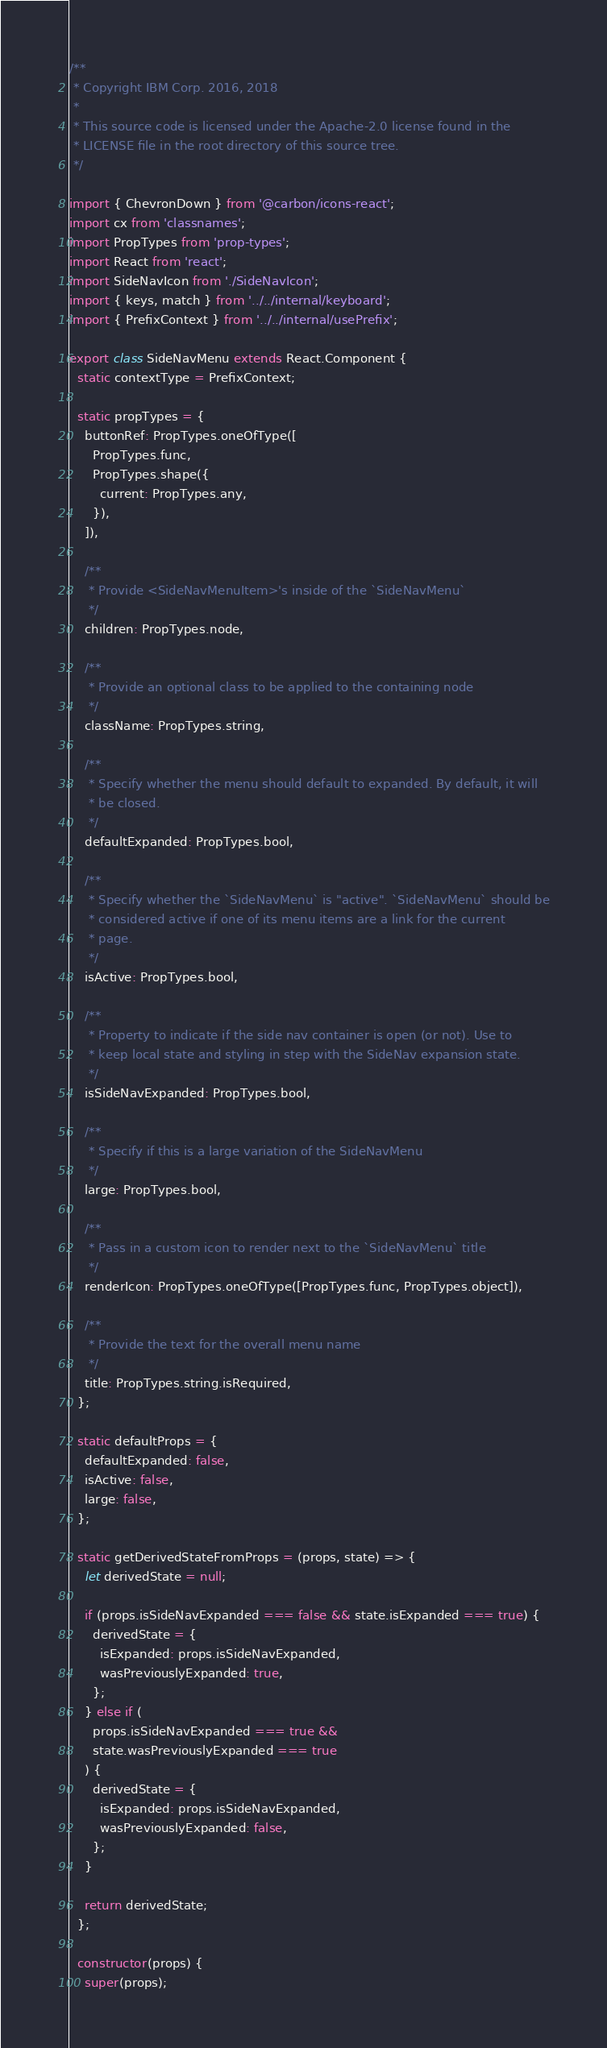<code> <loc_0><loc_0><loc_500><loc_500><_JavaScript_>/**
 * Copyright IBM Corp. 2016, 2018
 *
 * This source code is licensed under the Apache-2.0 license found in the
 * LICENSE file in the root directory of this source tree.
 */

import { ChevronDown } from '@carbon/icons-react';
import cx from 'classnames';
import PropTypes from 'prop-types';
import React from 'react';
import SideNavIcon from './SideNavIcon';
import { keys, match } from '../../internal/keyboard';
import { PrefixContext } from '../../internal/usePrefix';

export class SideNavMenu extends React.Component {
  static contextType = PrefixContext;

  static propTypes = {
    buttonRef: PropTypes.oneOfType([
      PropTypes.func,
      PropTypes.shape({
        current: PropTypes.any,
      }),
    ]),

    /**
     * Provide <SideNavMenuItem>'s inside of the `SideNavMenu`
     */
    children: PropTypes.node,

    /**
     * Provide an optional class to be applied to the containing node
     */
    className: PropTypes.string,

    /**
     * Specify whether the menu should default to expanded. By default, it will
     * be closed.
     */
    defaultExpanded: PropTypes.bool,

    /**
     * Specify whether the `SideNavMenu` is "active". `SideNavMenu` should be
     * considered active if one of its menu items are a link for the current
     * page.
     */
    isActive: PropTypes.bool,

    /**
     * Property to indicate if the side nav container is open (or not). Use to
     * keep local state and styling in step with the SideNav expansion state.
     */
    isSideNavExpanded: PropTypes.bool,

    /**
     * Specify if this is a large variation of the SideNavMenu
     */
    large: PropTypes.bool,

    /**
     * Pass in a custom icon to render next to the `SideNavMenu` title
     */
    renderIcon: PropTypes.oneOfType([PropTypes.func, PropTypes.object]),

    /**
     * Provide the text for the overall menu name
     */
    title: PropTypes.string.isRequired,
  };

  static defaultProps = {
    defaultExpanded: false,
    isActive: false,
    large: false,
  };

  static getDerivedStateFromProps = (props, state) => {
    let derivedState = null;

    if (props.isSideNavExpanded === false && state.isExpanded === true) {
      derivedState = {
        isExpanded: props.isSideNavExpanded,
        wasPreviouslyExpanded: true,
      };
    } else if (
      props.isSideNavExpanded === true &&
      state.wasPreviouslyExpanded === true
    ) {
      derivedState = {
        isExpanded: props.isSideNavExpanded,
        wasPreviouslyExpanded: false,
      };
    }

    return derivedState;
  };

  constructor(props) {
    super(props);</code> 